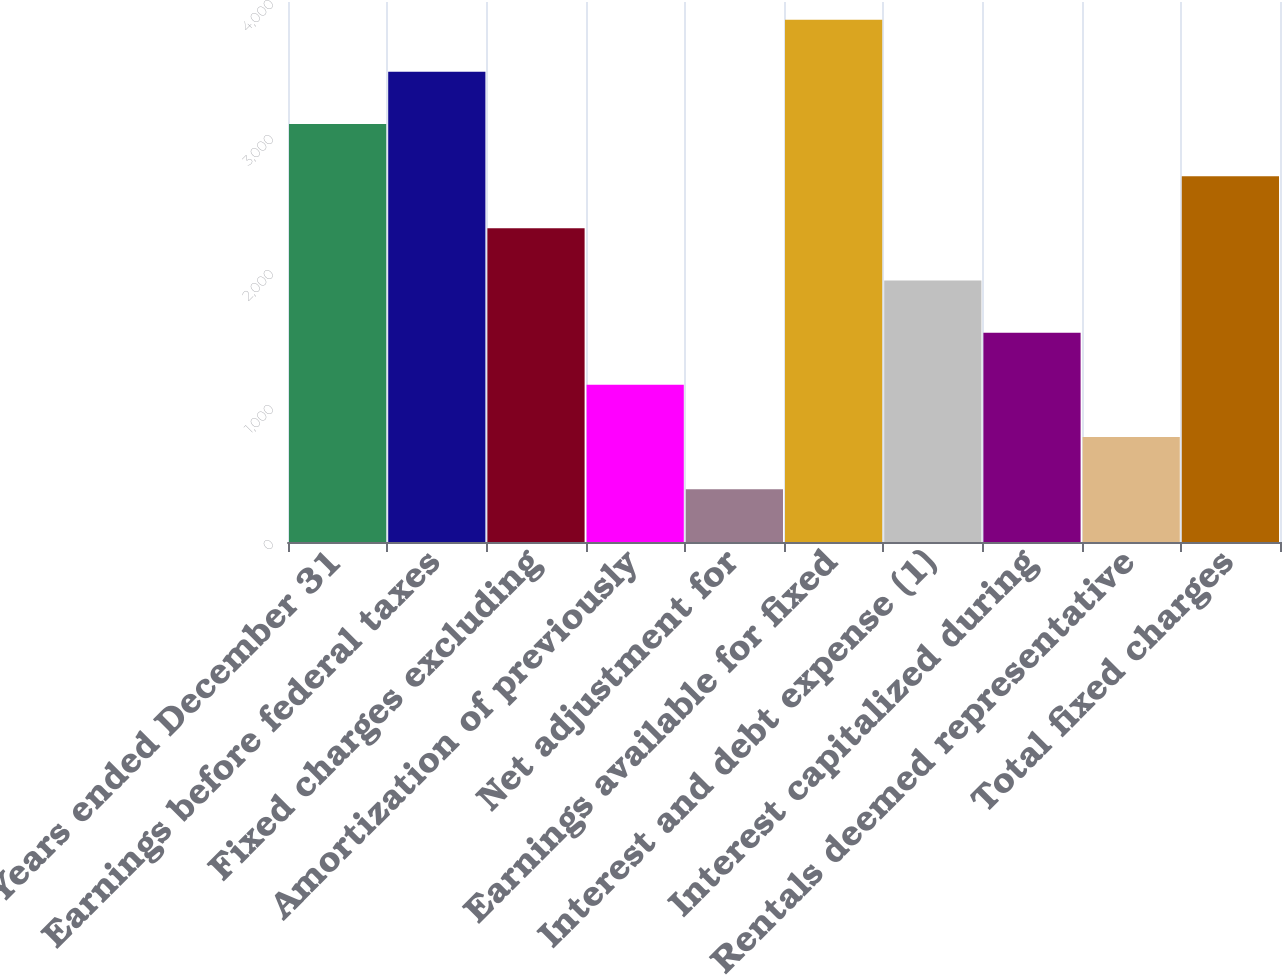Convert chart to OTSL. <chart><loc_0><loc_0><loc_500><loc_500><bar_chart><fcel>Years ended December 31<fcel>Earnings before federal taxes<fcel>Fixed charges excluding<fcel>Amortization of previously<fcel>Net adjustment for<fcel>Earnings available for fixed<fcel>Interest and debt expense (1)<fcel>Interest capitalized during<fcel>Rentals deemed representative<fcel>Total fixed charges<nl><fcel>3096.24<fcel>3482.62<fcel>2323.48<fcel>1164.34<fcel>391.58<fcel>3869<fcel>1937.1<fcel>1550.72<fcel>777.96<fcel>2709.86<nl></chart> 